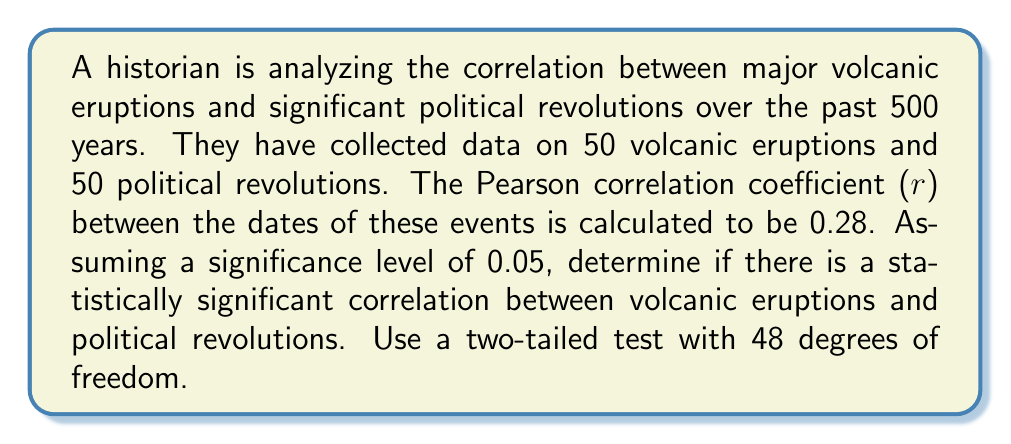Give your solution to this math problem. To determine if there is a statistically significant correlation, we'll follow these steps:

1. State the null and alternative hypotheses:
   $H_0: \rho = 0$ (no correlation)
   $H_a: \rho \neq 0$ (correlation exists)

2. Calculate the test statistic:
   The test statistic for Pearson's correlation is:
   $$t = r \sqrt{\frac{n-2}{1-r^2}}$$
   where r is the sample correlation coefficient and n is the sample size.

   $t = 0.28 \sqrt{\frac{50-2}{1-0.28^2}} = 2.023$

3. Determine the critical value:
   For a two-tailed test with 48 degrees of freedom (n-2) and α = 0.05, the critical value is:
   $t_{crit} = \pm 2.011$

4. Compare the test statistic to the critical value:
   $|t| = 2.023 > t_{crit} = 2.011$

5. Calculate the p-value:
   Using a t-distribution calculator with 48 degrees of freedom:
   $p-value \approx 0.0488$

6. Make a decision:
   Since $|t| > t_{crit}$ and $p-value < 0.05$, we reject the null hypothesis.
Answer: Statistically significant correlation (p = 0.0488) 